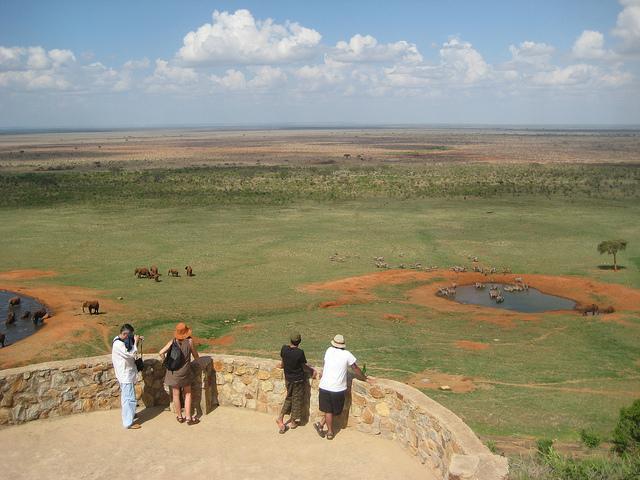How many people are standing at the wall?
Give a very brief answer. 4. How many people can you see?
Give a very brief answer. 2. How many rolls of toilet paper are on the wall?
Give a very brief answer. 0. 